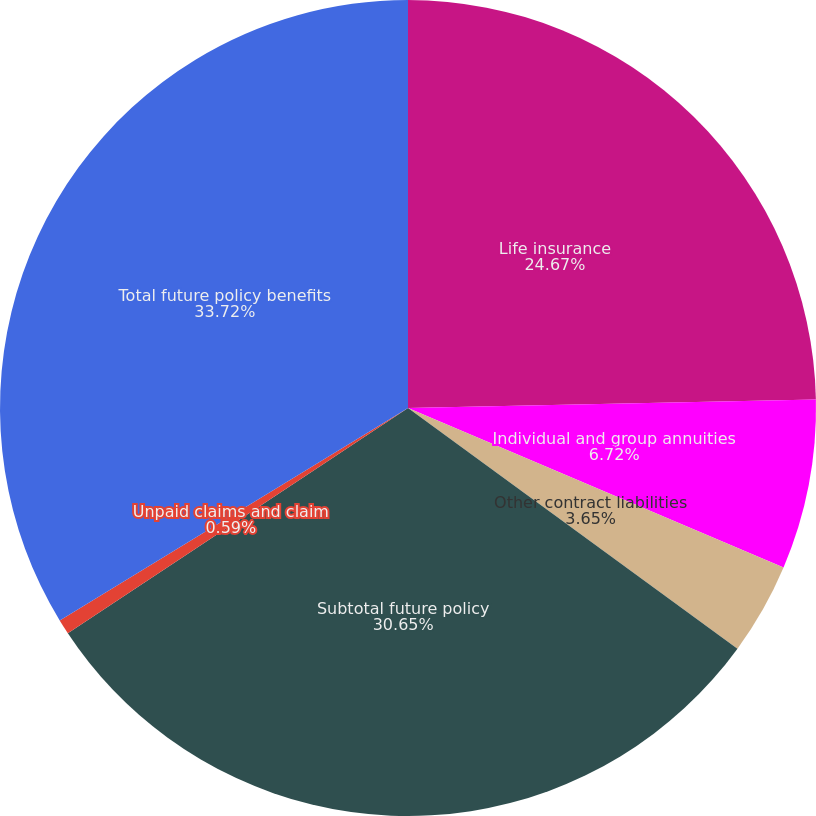<chart> <loc_0><loc_0><loc_500><loc_500><pie_chart><fcel>Life insurance<fcel>Individual and group annuities<fcel>Other contract liabilities<fcel>Subtotal future policy<fcel>Unpaid claims and claim<fcel>Total future policy benefits<nl><fcel>24.67%<fcel>6.72%<fcel>3.65%<fcel>30.65%<fcel>0.59%<fcel>33.72%<nl></chart> 